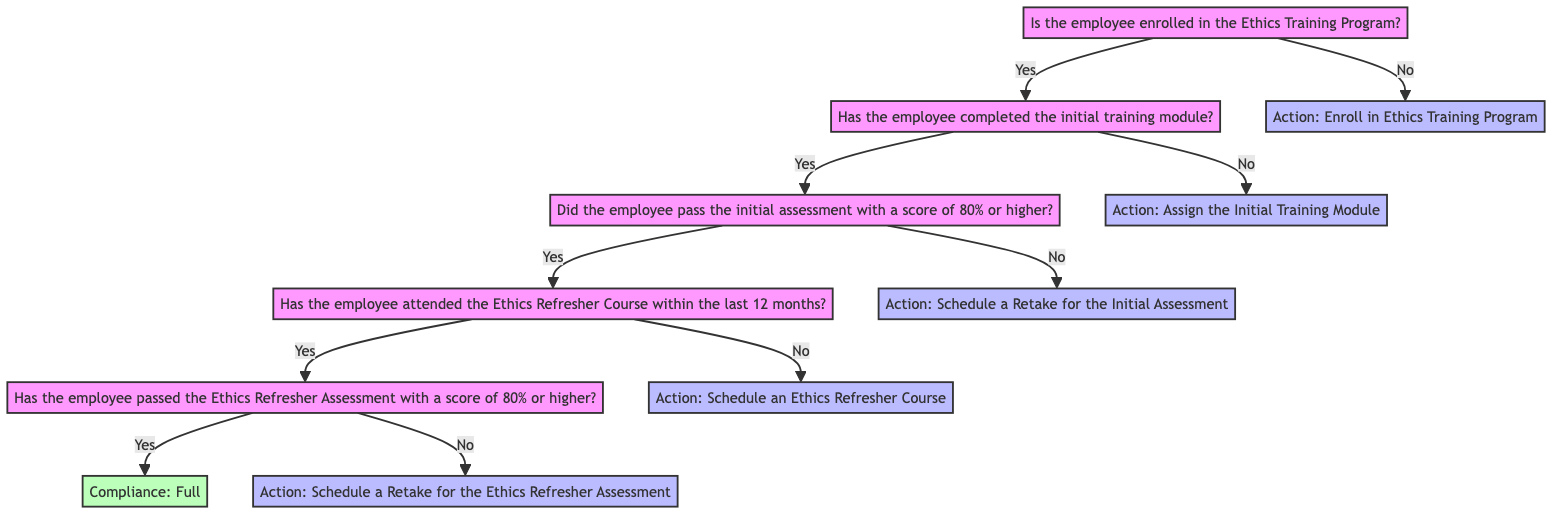What is the first action for employees not enrolled in the Ethics Training Program? According to the diagram, if the employee is not enrolled in the Ethics Training Program, the action is to "Enroll in Ethics Training Program." This is the direct output from the starting node that leads to the action for non-enrollment.
Answer: Enroll in Ethics Training Program What needs to be done if the employee has not completed the initial training module? The diagram indicates that if the employee has not completed the initial training module, the next action is to "Assign the Initial Training Module." This is reached by following the "No" branch from the "Has the employee completed the initial training module?" node.
Answer: Assign the Initial Training Module How many assessments must the employee pass to achieve full compliance? The employee must pass two assessments: the initial assessment and the Ethics Refresher Assessment. These are observed sequentially in the diagram, as both assessments are necessary conditions for the "Compliance: Full" outcome.
Answer: Two If the employee attended the Ethics Refresher Course but did not pass the Ethics Refresher Assessment, what is the next step? The next step is to "Schedule a Retake for the Ethics Refresher Assessment." This follows from the node that checks whether the employee passed the Ethics Refresher Assessment, leading to the action when the answer is "No."
Answer: Schedule a Retake for the Ethics Refresher Assessment What action should an employee take if they passed the initial assessment but have not attended the Ethics Refresher Course within the last 12 months? The diagram specifies that in this case, the employee should "Schedule an Ethics Refresher Course." Following the "Yes" path from the initial assessment that leads to the check for attendance confirms this action.
Answer: Schedule an Ethics Refresher Course What does the diagram indicate if an employee passes both assessments and attends the refresher course? If the employee passes both assessments and has attended the refresher course, they achieve the status: "Compliance: Full." This is the outcome derived from successful navigation through the decision tree without hitting any action prompts.
Answer: Compliance: Full If an employee completes the initial training but scores below 80% on the initial assessment, what should happen next? The diagram indicates that if the employee scores below 80% on the initial assessment, the action should be to "Schedule a Retake for the Initial Assessment." This is derived from the "No" branch stemming from the assessment score check.
Answer: Schedule a Retake for the Initial Assessment What is the outcome if an employee is both enrolled and completed the initial training module? If both conditions are satisfied, the diagram then prompts the evaluation of the next condition about passing the initial assessment. Since this is a question about the flow, the employee's current situation leads to further assessment requirements rather than a clear outcome yet. There's no final outcome immediately reached at this point.
Answer: Continue assessment process 